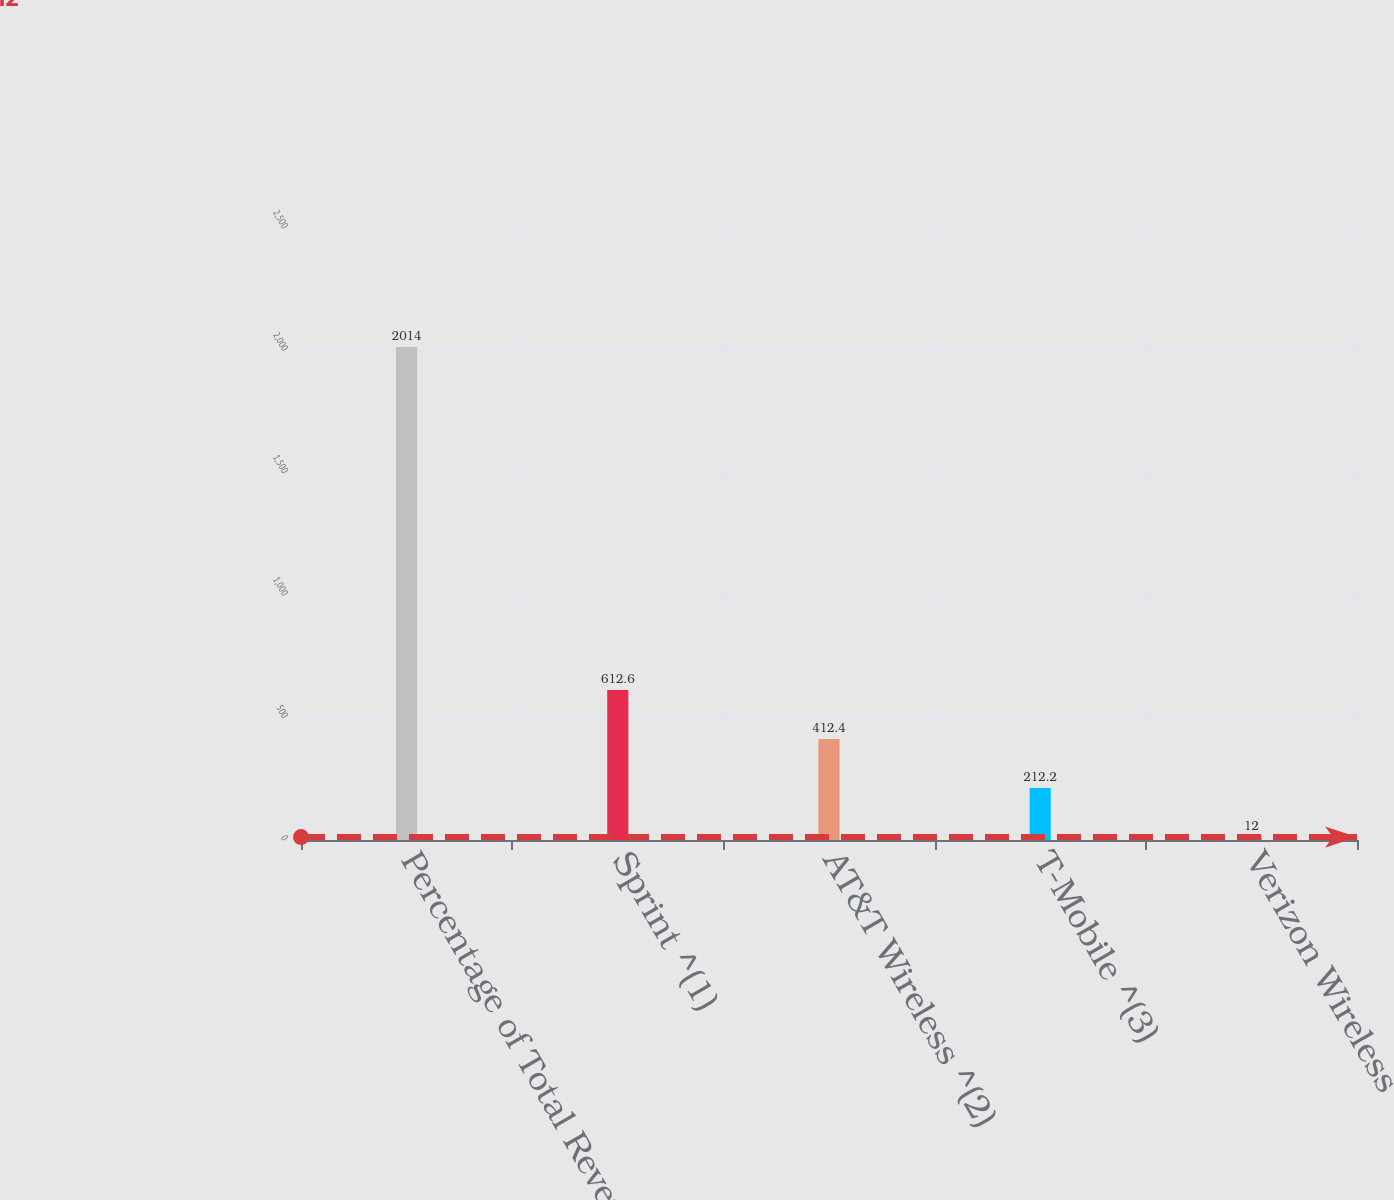Convert chart to OTSL. <chart><loc_0><loc_0><loc_500><loc_500><bar_chart><fcel>Percentage of Total Revenues<fcel>Sprint ^(1)<fcel>AT&T Wireless ^(2)<fcel>T-Mobile ^(3)<fcel>Verizon Wireless<nl><fcel>2014<fcel>612.6<fcel>412.4<fcel>212.2<fcel>12<nl></chart> 